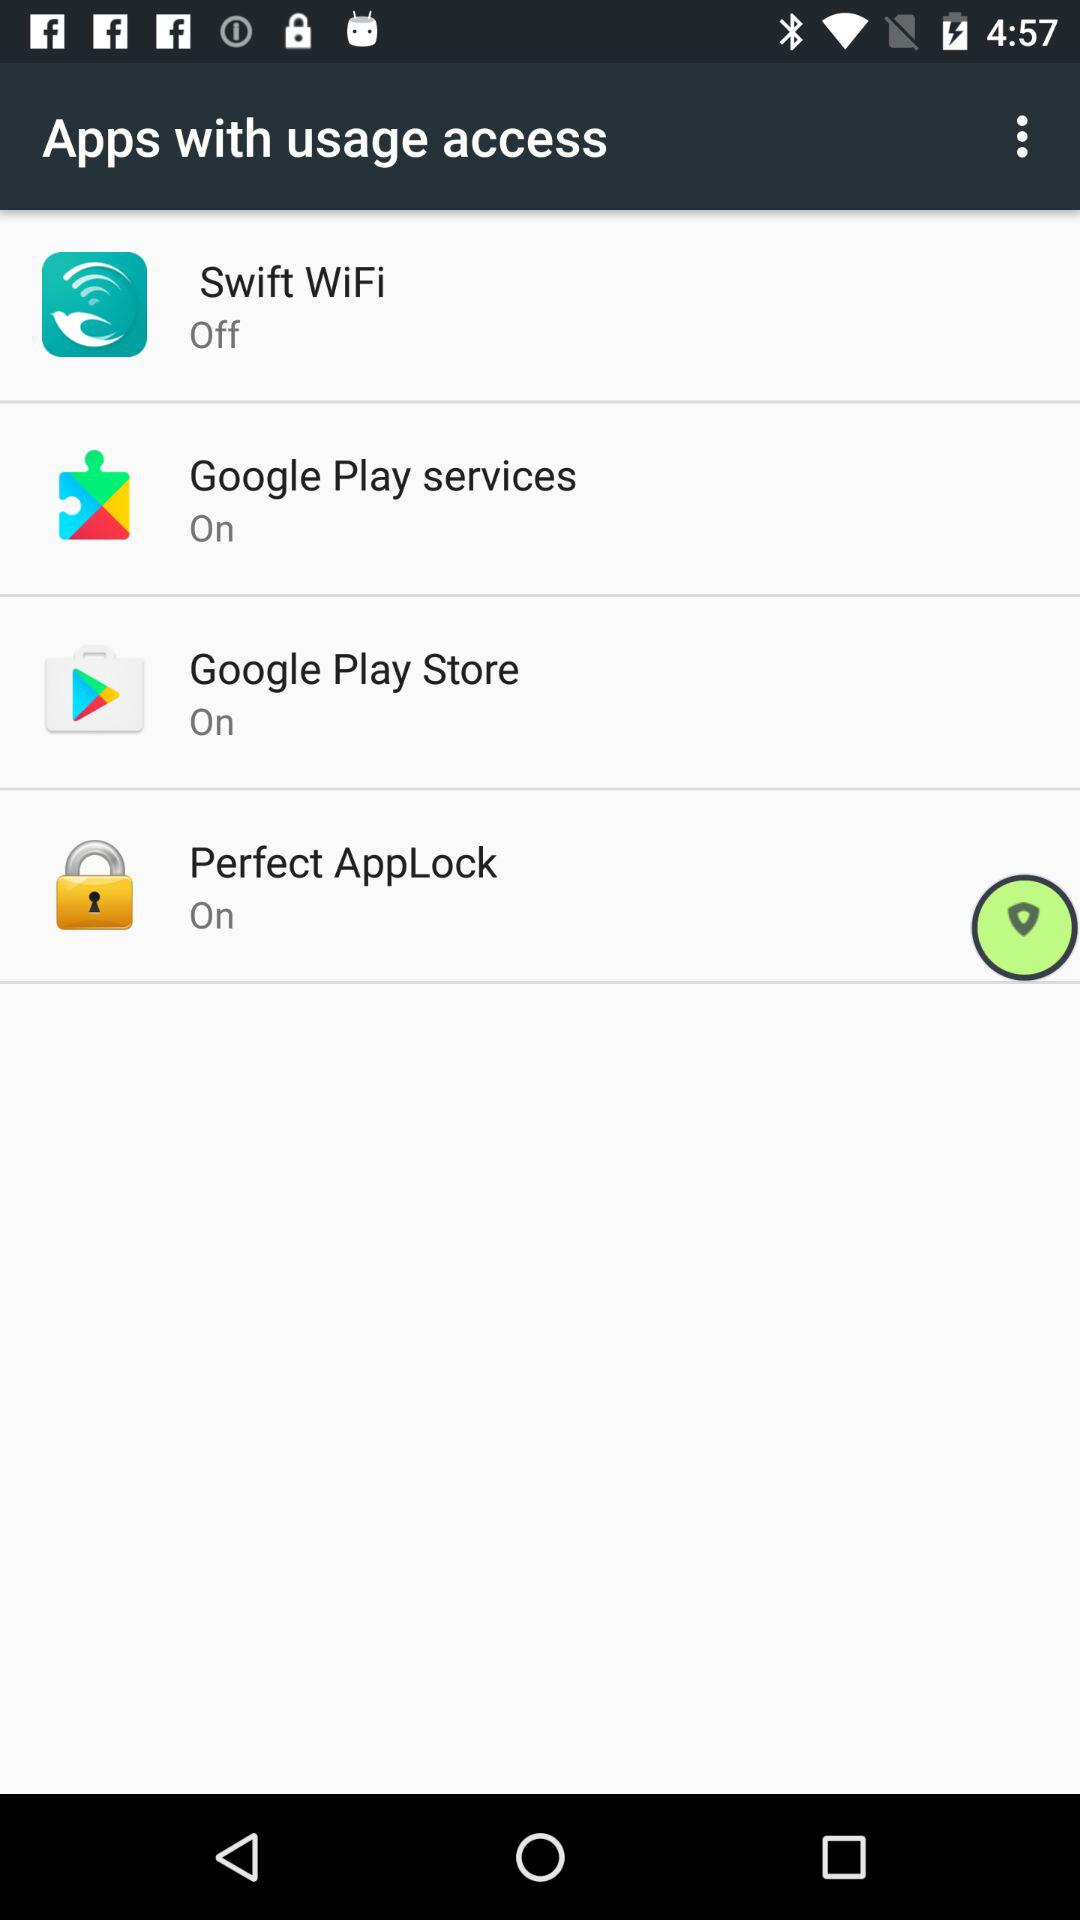How many apps are turned on?
Answer the question using a single word or phrase. 3 